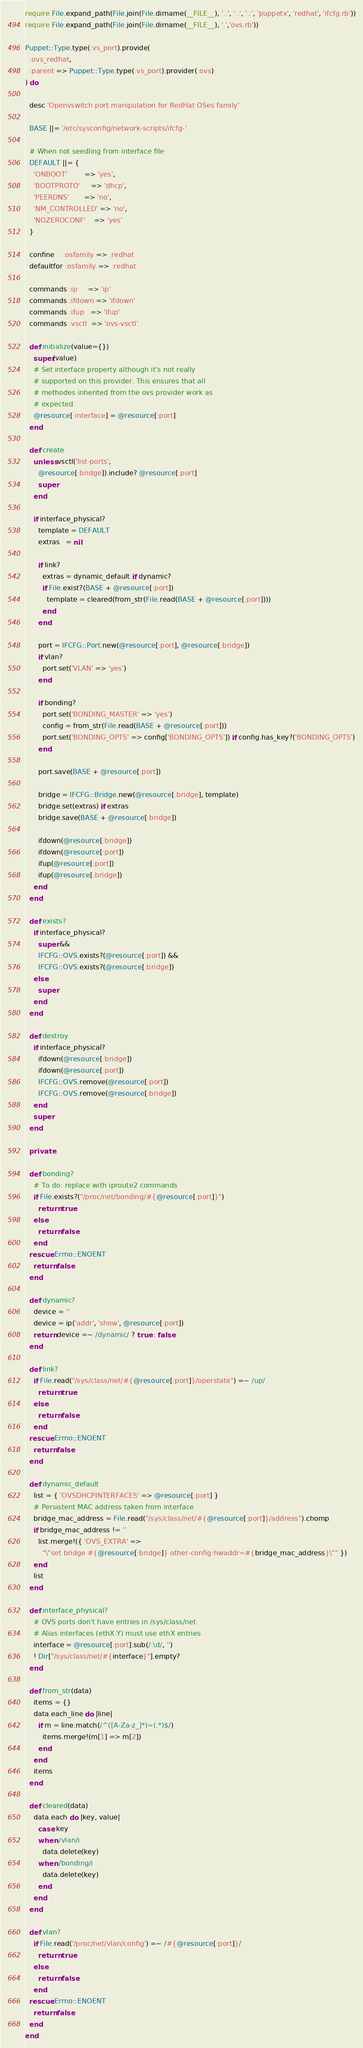<code> <loc_0><loc_0><loc_500><loc_500><_Ruby_>require File.expand_path(File.join(File.dirname(__FILE__), '..', '..', '..', 'puppetx', 'redhat', 'ifcfg.rb'))
require File.expand_path(File.join(File.dirname(__FILE__), '.','ovs.rb'))

Puppet::Type.type(:vs_port).provide(
  :ovs_redhat,
  :parent => Puppet::Type.type(:vs_port).provider(:ovs)
) do

  desc 'Openvswitch port manipulation for RedHat OSes family'

  BASE ||= '/etc/sysconfig/network-scripts/ifcfg-'

  # When not seedling from interface file
  DEFAULT ||= {
    'ONBOOT'        => 'yes',
    'BOOTPROTO'     => 'dhcp',
    'PEERDNS'       => 'no',
    'NM_CONTROLLED' => 'no',
    'NOZEROCONF'    => 'yes'
  }

  confine    :osfamily => :redhat
  defaultfor :osfamily => :redhat

  commands :ip     => 'ip'
  commands :ifdown => 'ifdown'
  commands :ifup   => 'ifup'
  commands :vsctl  => 'ovs-vsctl'

  def initialize(value={})
    super(value)
    # Set interface property although it's not really
    # supported on this provider. This ensures that all
    # methodes inherited from the ovs provider work as
    # expected.
    @resource[:interface] = @resource[:port]
  end

  def create
    unless vsctl('list-ports',
      @resource[:bridge]).include? @resource[:port]
      super
    end

    if interface_physical?
      template = DEFAULT
      extras   = nil

      if link?
        extras = dynamic_default if dynamic?
        if File.exist?(BASE + @resource[:port])
          template = cleared(from_str(File.read(BASE + @resource[:port])))
        end
      end

      port = IFCFG::Port.new(@resource[:port], @resource[:bridge])
      if vlan?
        port.set('VLAN' => 'yes')
      end

      if bonding?
        port.set('BONDING_MASTER' => 'yes')
        config = from_str(File.read(BASE + @resource[:port]))
        port.set('BONDING_OPTS' => config['BONDING_OPTS']) if config.has_key?('BONDING_OPTS')
      end

      port.save(BASE + @resource[:port])

      bridge = IFCFG::Bridge.new(@resource[:bridge], template)
      bridge.set(extras) if extras
      bridge.save(BASE + @resource[:bridge])

      ifdown(@resource[:bridge])
      ifdown(@resource[:port])
      ifup(@resource[:port])
      ifup(@resource[:bridge])
    end
  end

  def exists?
    if interface_physical?
      super &&
      IFCFG::OVS.exists?(@resource[:port]) &&
      IFCFG::OVS.exists?(@resource[:bridge])
    else
      super
    end
  end

  def destroy
    if interface_physical?
      ifdown(@resource[:bridge])
      ifdown(@resource[:port])
      IFCFG::OVS.remove(@resource[:port])
      IFCFG::OVS.remove(@resource[:bridge])
    end
    super
  end

  private

  def bonding?
    # To do: replace with iproute2 commands
    if File.exists?("/proc/net/bonding/#{@resource[:port]}")
      return true
    else
      return false
    end
  rescue Errno::ENOENT
    return false
  end

  def dynamic?
    device = ''
    device = ip('addr', 'show', @resource[:port])
    return device =~ /dynamic/ ? true : false
  end

  def link?
    if File.read("/sys/class/net/#{@resource[:port]}/operstate") =~ /up/
      return true
    else
      return false
    end
  rescue Errno::ENOENT
    return false
  end

  def dynamic_default
    list = { 'OVSDHCPINTERFACES' => @resource[:port] }
    # Persistent MAC address taken from interface
    bridge_mac_address = File.read("/sys/class/net/#{@resource[:port]}/address").chomp
    if bridge_mac_address != ''
      list.merge!({ 'OVS_EXTRA' =>
        "\"set bridge #{@resource[:bridge]} other-config:hwaddr=#{bridge_mac_address}\"" })
    end
    list
  end

  def interface_physical?
    # OVS ports don't have entries in /sys/class/net
    # Alias interfaces (ethX:Y) must use ethX entries
    interface = @resource[:port].sub(/:\d/, '')
    ! Dir["/sys/class/net/#{interface}"].empty?
  end

  def from_str(data)
    items = {}
    data.each_line do |line|
      if m = line.match(/^([A-Za-z_]*)=(.*)$/)
        items.merge!(m[1] => m[2])
      end
    end
    items
  end

  def cleared(data)
    data.each do |key, value|
      case key
      when /vlan/i
        data.delete(key)
      when /bonding/i
        data.delete(key)
      end
    end
  end

  def vlan?
    if File.read('/proc/net/vlan/config') =~ /#{@resource[:port]}/
      return true
    else
      return false
    end
  rescue Errno::ENOENT
    return false
  end
end
</code> 